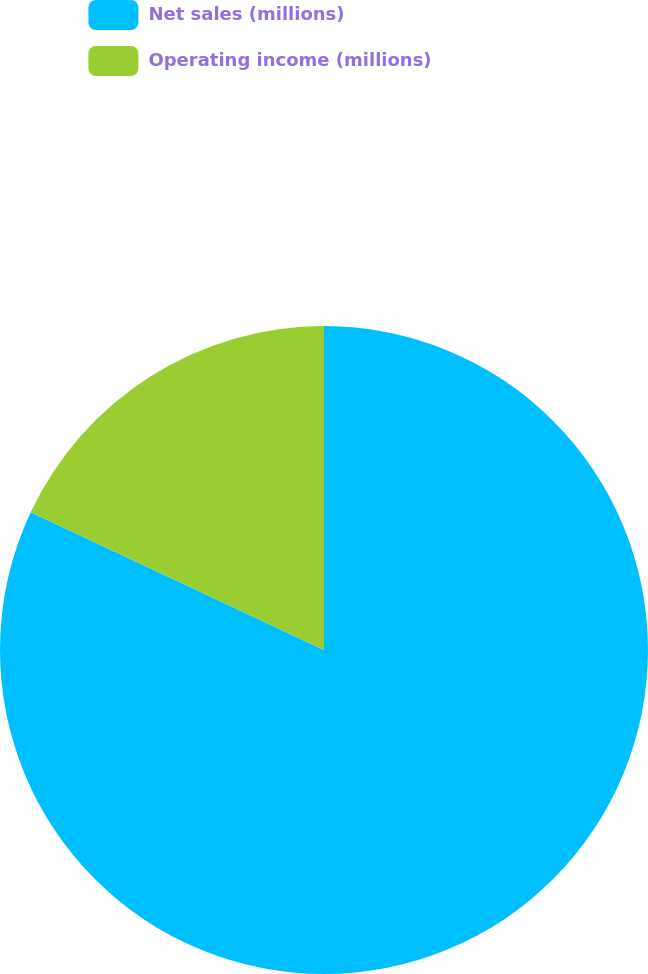Convert chart. <chart><loc_0><loc_0><loc_500><loc_500><pie_chart><fcel>Net sales (millions)<fcel>Operating income (millions)<nl><fcel>81.99%<fcel>18.01%<nl></chart> 